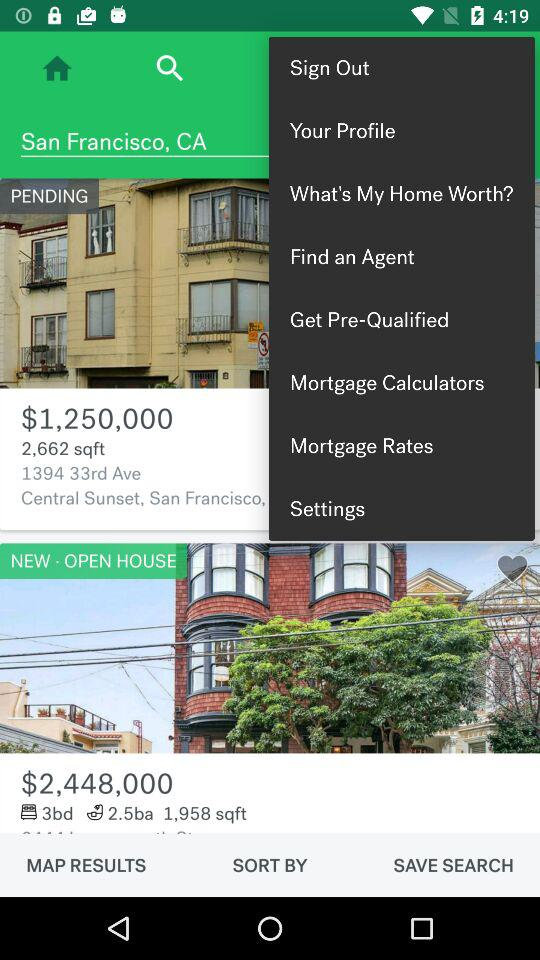What is the area of the house with a pending status? The area is 2,662 square feet. 